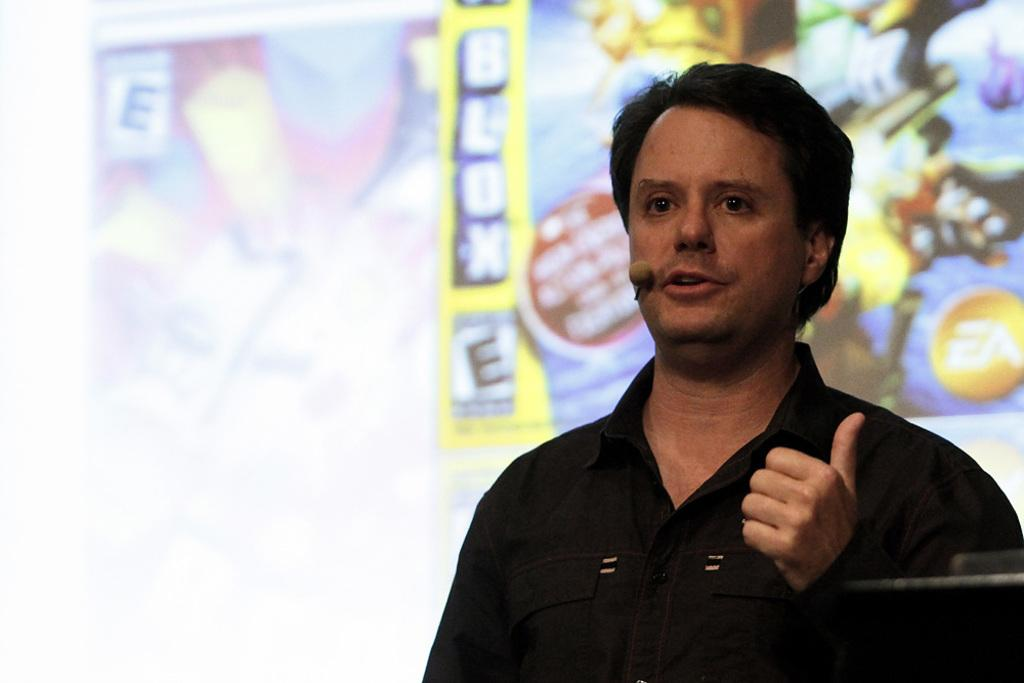Who is the main subject in the image? There is a man in the image. What is the man doing in the image? The man is speaking in the image. What tool is the man using to amplify his voice? The man is using a microphone in the image. What can be seen in the background of the image? There are posts visible in the background of the image. What type of mint is growing on the man's head in the image? There is no mint or any plant growing on the man's head in the image. 